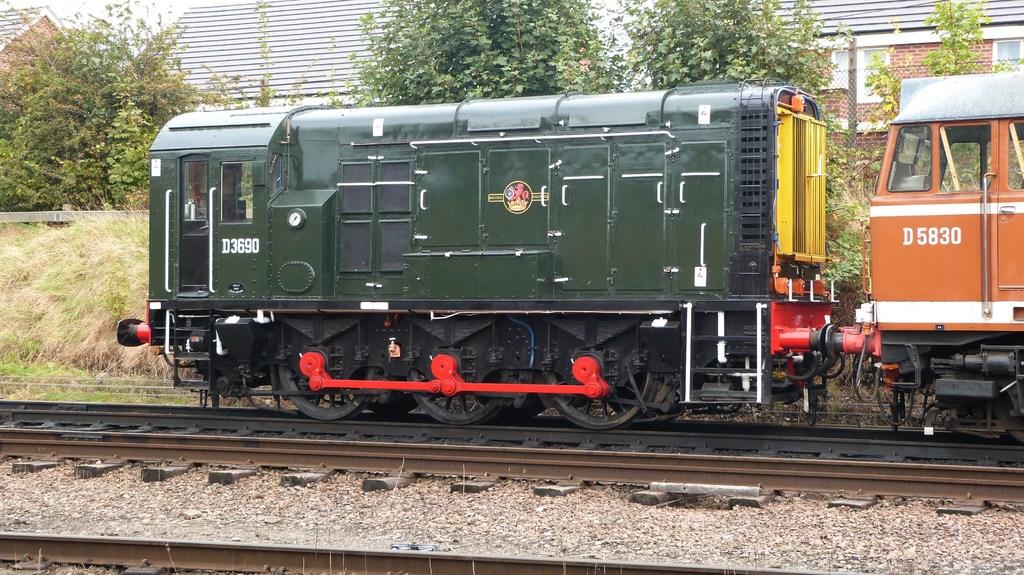What is written on the orange train car?
Ensure brevity in your answer.  D5830. What code is on the green train in white letters and numbers?
Make the answer very short. D3690. 